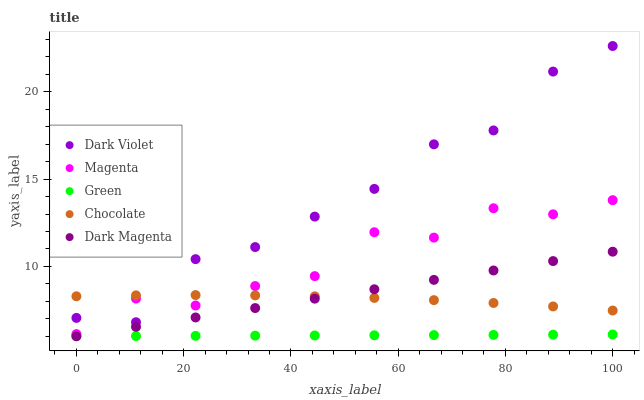Does Green have the minimum area under the curve?
Answer yes or no. Yes. Does Dark Violet have the maximum area under the curve?
Answer yes or no. Yes. Does Dark Magenta have the minimum area under the curve?
Answer yes or no. No. Does Dark Magenta have the maximum area under the curve?
Answer yes or no. No. Is Green the smoothest?
Answer yes or no. Yes. Is Dark Violet the roughest?
Answer yes or no. Yes. Is Dark Magenta the smoothest?
Answer yes or no. No. Is Dark Magenta the roughest?
Answer yes or no. No. Does Green have the lowest value?
Answer yes or no. Yes. Does Dark Violet have the lowest value?
Answer yes or no. No. Does Dark Violet have the highest value?
Answer yes or no. Yes. Does Dark Magenta have the highest value?
Answer yes or no. No. Is Green less than Chocolate?
Answer yes or no. Yes. Is Chocolate greater than Green?
Answer yes or no. Yes. Does Chocolate intersect Dark Magenta?
Answer yes or no. Yes. Is Chocolate less than Dark Magenta?
Answer yes or no. No. Is Chocolate greater than Dark Magenta?
Answer yes or no. No. Does Green intersect Chocolate?
Answer yes or no. No. 